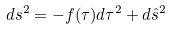<formula> <loc_0><loc_0><loc_500><loc_500>d s ^ { 2 } = - f ( \tau ) d \tau ^ { 2 } + d \hat { s } ^ { 2 }</formula> 